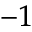<formula> <loc_0><loc_0><loc_500><loc_500>^ { - 1 }</formula> 